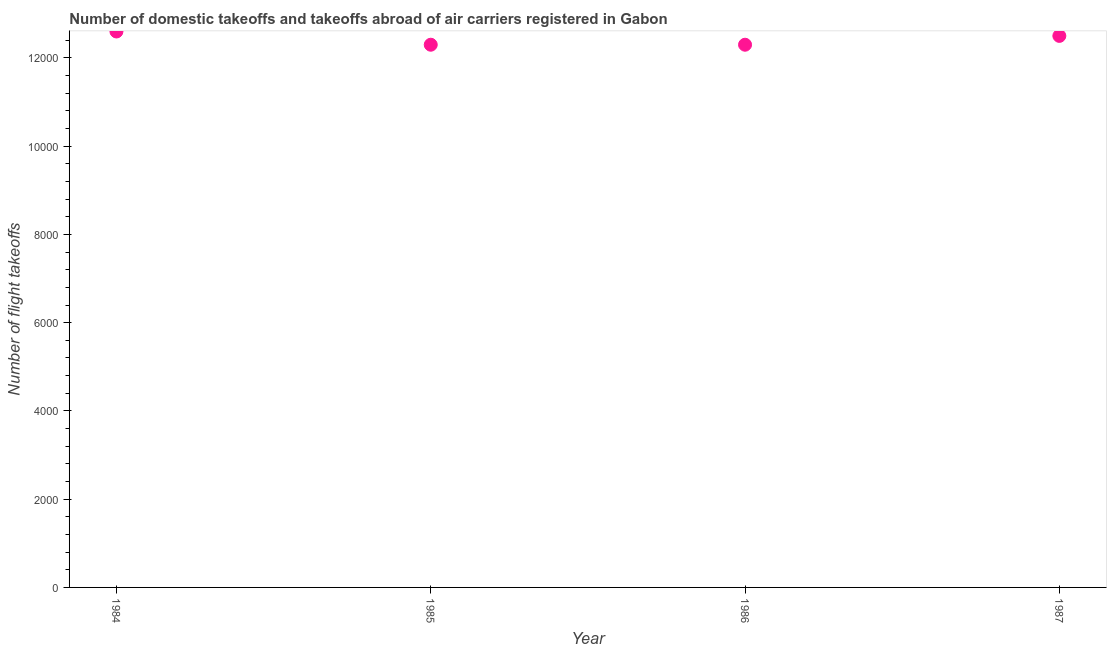What is the number of flight takeoffs in 1987?
Provide a succinct answer. 1.25e+04. Across all years, what is the maximum number of flight takeoffs?
Offer a very short reply. 1.26e+04. Across all years, what is the minimum number of flight takeoffs?
Your response must be concise. 1.23e+04. In which year was the number of flight takeoffs maximum?
Your answer should be compact. 1984. In which year was the number of flight takeoffs minimum?
Provide a succinct answer. 1985. What is the sum of the number of flight takeoffs?
Offer a very short reply. 4.97e+04. What is the difference between the number of flight takeoffs in 1985 and 1986?
Give a very brief answer. 0. What is the average number of flight takeoffs per year?
Offer a very short reply. 1.24e+04. What is the median number of flight takeoffs?
Offer a terse response. 1.24e+04. Do a majority of the years between 1985 and 1987 (inclusive) have number of flight takeoffs greater than 7600 ?
Provide a succinct answer. Yes. What is the ratio of the number of flight takeoffs in 1985 to that in 1986?
Provide a short and direct response. 1. Is the number of flight takeoffs in 1985 less than that in 1986?
Keep it short and to the point. No. What is the difference between the highest and the second highest number of flight takeoffs?
Offer a terse response. 100. Is the sum of the number of flight takeoffs in 1985 and 1986 greater than the maximum number of flight takeoffs across all years?
Offer a terse response. Yes. What is the difference between the highest and the lowest number of flight takeoffs?
Make the answer very short. 300. What is the difference between two consecutive major ticks on the Y-axis?
Your answer should be compact. 2000. Are the values on the major ticks of Y-axis written in scientific E-notation?
Make the answer very short. No. What is the title of the graph?
Provide a short and direct response. Number of domestic takeoffs and takeoffs abroad of air carriers registered in Gabon. What is the label or title of the Y-axis?
Ensure brevity in your answer.  Number of flight takeoffs. What is the Number of flight takeoffs in 1984?
Make the answer very short. 1.26e+04. What is the Number of flight takeoffs in 1985?
Your answer should be compact. 1.23e+04. What is the Number of flight takeoffs in 1986?
Give a very brief answer. 1.23e+04. What is the Number of flight takeoffs in 1987?
Offer a terse response. 1.25e+04. What is the difference between the Number of flight takeoffs in 1984 and 1985?
Your response must be concise. 300. What is the difference between the Number of flight takeoffs in 1984 and 1986?
Give a very brief answer. 300. What is the difference between the Number of flight takeoffs in 1985 and 1986?
Your response must be concise. 0. What is the difference between the Number of flight takeoffs in 1985 and 1987?
Ensure brevity in your answer.  -200. What is the difference between the Number of flight takeoffs in 1986 and 1987?
Provide a short and direct response. -200. What is the ratio of the Number of flight takeoffs in 1984 to that in 1986?
Your answer should be very brief. 1.02. What is the ratio of the Number of flight takeoffs in 1985 to that in 1986?
Offer a terse response. 1. What is the ratio of the Number of flight takeoffs in 1985 to that in 1987?
Provide a short and direct response. 0.98. 